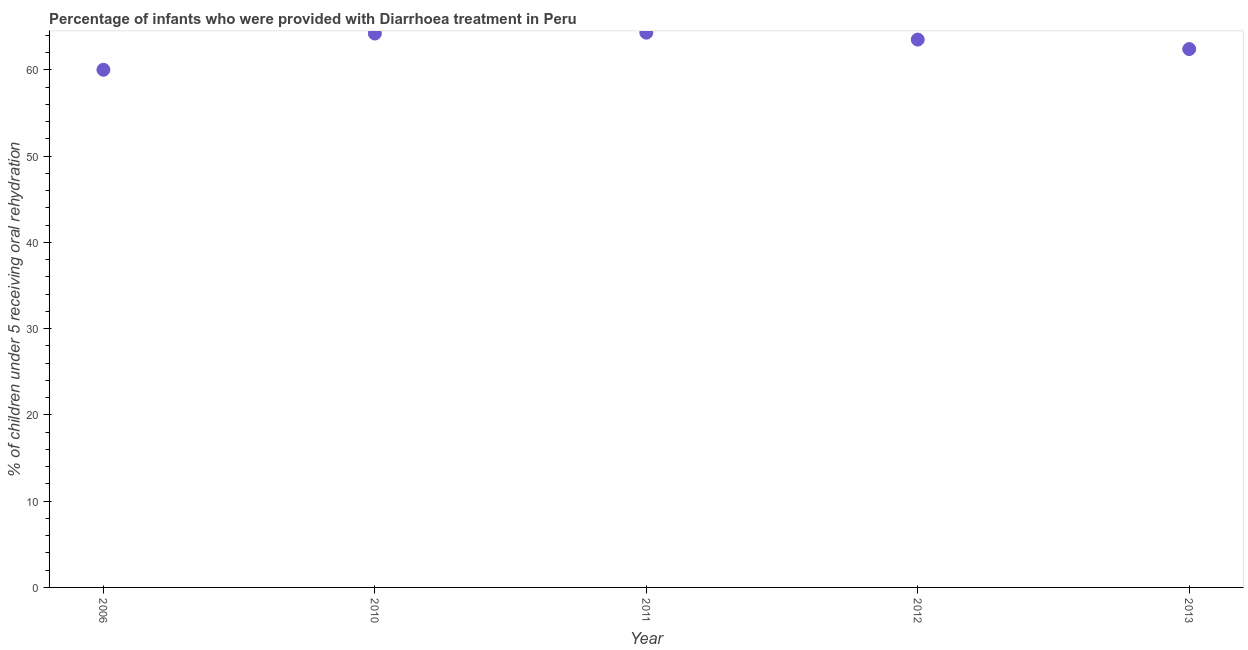What is the percentage of children who were provided with treatment diarrhoea in 2013?
Your answer should be compact. 62.4. Across all years, what is the maximum percentage of children who were provided with treatment diarrhoea?
Give a very brief answer. 64.3. Across all years, what is the minimum percentage of children who were provided with treatment diarrhoea?
Offer a terse response. 60. In which year was the percentage of children who were provided with treatment diarrhoea minimum?
Your answer should be compact. 2006. What is the sum of the percentage of children who were provided with treatment diarrhoea?
Ensure brevity in your answer.  314.4. What is the difference between the percentage of children who were provided with treatment diarrhoea in 2010 and 2012?
Keep it short and to the point. 0.7. What is the average percentage of children who were provided with treatment diarrhoea per year?
Give a very brief answer. 62.88. What is the median percentage of children who were provided with treatment diarrhoea?
Offer a terse response. 63.5. In how many years, is the percentage of children who were provided with treatment diarrhoea greater than 6 %?
Give a very brief answer. 5. Do a majority of the years between 2012 and 2010 (inclusive) have percentage of children who were provided with treatment diarrhoea greater than 26 %?
Ensure brevity in your answer.  No. What is the ratio of the percentage of children who were provided with treatment diarrhoea in 2010 to that in 2013?
Ensure brevity in your answer.  1.03. Is the percentage of children who were provided with treatment diarrhoea in 2012 less than that in 2013?
Make the answer very short. No. What is the difference between the highest and the second highest percentage of children who were provided with treatment diarrhoea?
Provide a succinct answer. 0.1. What is the difference between the highest and the lowest percentage of children who were provided with treatment diarrhoea?
Ensure brevity in your answer.  4.3. In how many years, is the percentage of children who were provided with treatment diarrhoea greater than the average percentage of children who were provided with treatment diarrhoea taken over all years?
Make the answer very short. 3. How many years are there in the graph?
Ensure brevity in your answer.  5. What is the difference between two consecutive major ticks on the Y-axis?
Your response must be concise. 10. Does the graph contain any zero values?
Make the answer very short. No. What is the title of the graph?
Provide a short and direct response. Percentage of infants who were provided with Diarrhoea treatment in Peru. What is the label or title of the X-axis?
Your answer should be very brief. Year. What is the label or title of the Y-axis?
Your answer should be compact. % of children under 5 receiving oral rehydration. What is the % of children under 5 receiving oral rehydration in 2010?
Make the answer very short. 64.2. What is the % of children under 5 receiving oral rehydration in 2011?
Your response must be concise. 64.3. What is the % of children under 5 receiving oral rehydration in 2012?
Ensure brevity in your answer.  63.5. What is the % of children under 5 receiving oral rehydration in 2013?
Offer a terse response. 62.4. What is the difference between the % of children under 5 receiving oral rehydration in 2006 and 2010?
Provide a succinct answer. -4.2. What is the difference between the % of children under 5 receiving oral rehydration in 2006 and 2011?
Your answer should be very brief. -4.3. What is the difference between the % of children under 5 receiving oral rehydration in 2006 and 2012?
Your answer should be very brief. -3.5. What is the difference between the % of children under 5 receiving oral rehydration in 2006 and 2013?
Your answer should be compact. -2.4. What is the difference between the % of children under 5 receiving oral rehydration in 2010 and 2011?
Ensure brevity in your answer.  -0.1. What is the difference between the % of children under 5 receiving oral rehydration in 2010 and 2012?
Your answer should be compact. 0.7. What is the difference between the % of children under 5 receiving oral rehydration in 2011 and 2012?
Make the answer very short. 0.8. What is the difference between the % of children under 5 receiving oral rehydration in 2012 and 2013?
Your answer should be very brief. 1.1. What is the ratio of the % of children under 5 receiving oral rehydration in 2006 to that in 2010?
Offer a terse response. 0.94. What is the ratio of the % of children under 5 receiving oral rehydration in 2006 to that in 2011?
Your response must be concise. 0.93. What is the ratio of the % of children under 5 receiving oral rehydration in 2006 to that in 2012?
Provide a succinct answer. 0.94. What is the ratio of the % of children under 5 receiving oral rehydration in 2010 to that in 2013?
Offer a very short reply. 1.03. What is the ratio of the % of children under 5 receiving oral rehydration in 2011 to that in 2012?
Make the answer very short. 1.01. What is the ratio of the % of children under 5 receiving oral rehydration in 2011 to that in 2013?
Provide a short and direct response. 1.03. What is the ratio of the % of children under 5 receiving oral rehydration in 2012 to that in 2013?
Offer a terse response. 1.02. 